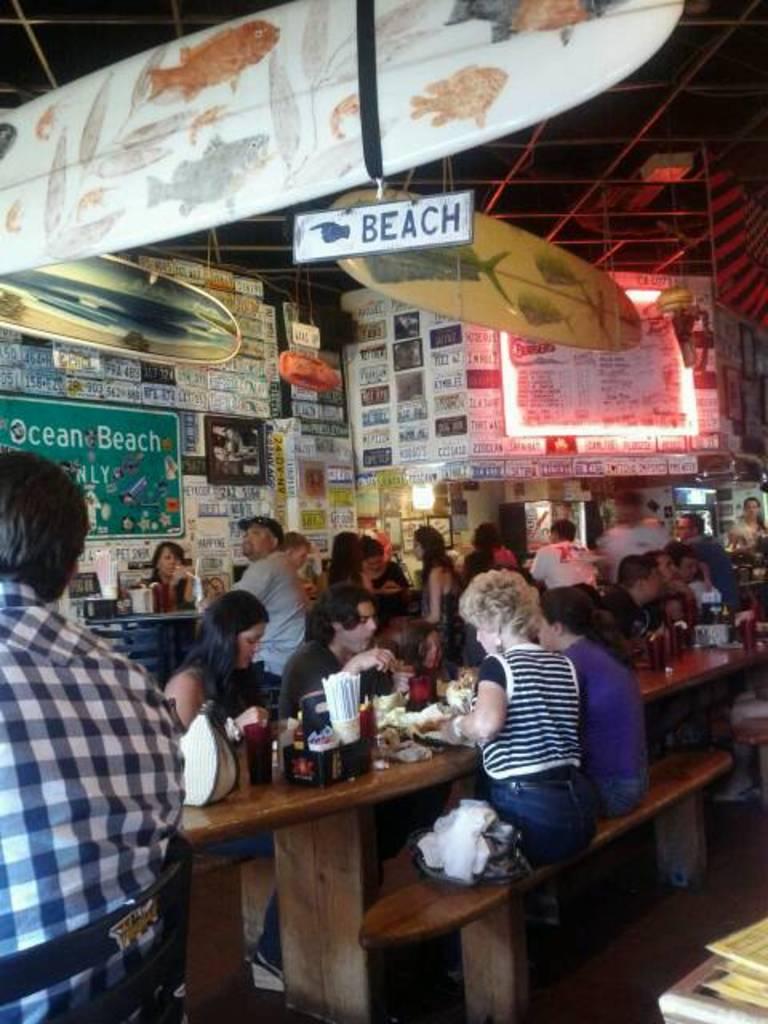Could you give a brief overview of what you see in this image? In this picture there are many people sitting on the bench. In front of them there is a table with many items on it. On top there are some posters, name board, banner and a surfboard on the top. 